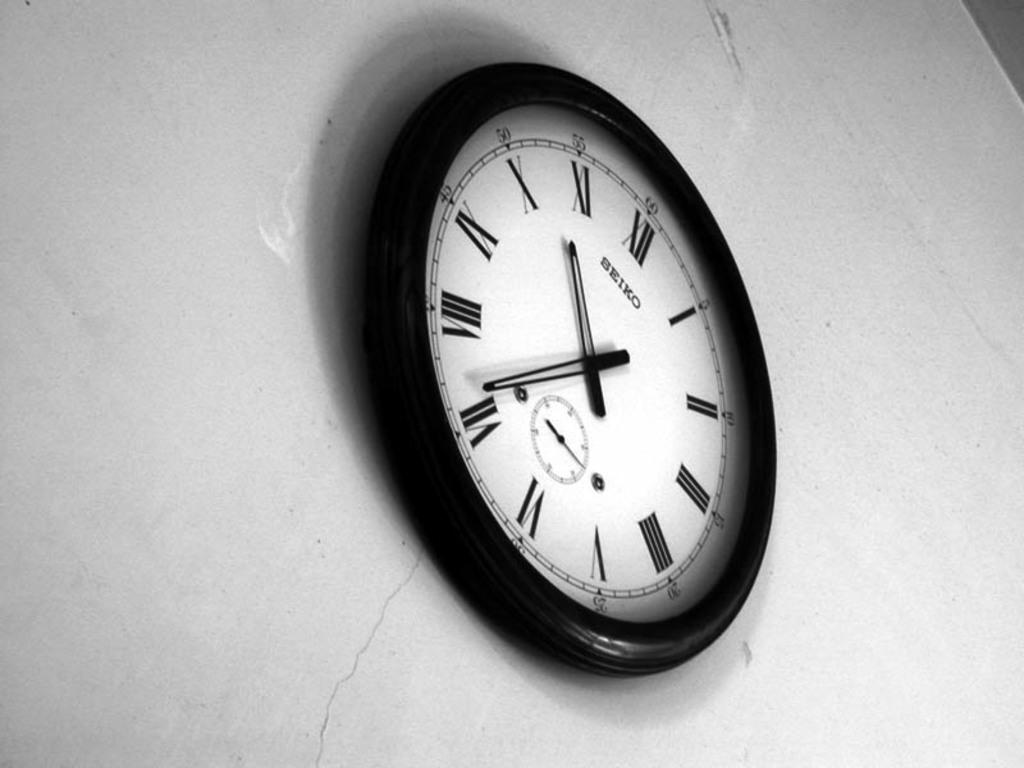What object is hanging on the wall in the image? There is a clock on the wall in the image. Can you describe the clock in more detail? Unfortunately, the provided facts do not give any additional details about the clock. What might the presence of a clock on the wall suggest about the setting? The presence of a clock on the wall suggests that the setting might be a room or area where people need to keep track of time. Are there any fairies flying around the clock in the image? There is no mention of fairies or any other fantastical elements in the image. The image only features a clock on the wall. Can you see the thumbprint of the person who hung the clock in the image? There is no indication of a thumbprint or any other personal touch in the image. The image only shows a clock on the wall. 